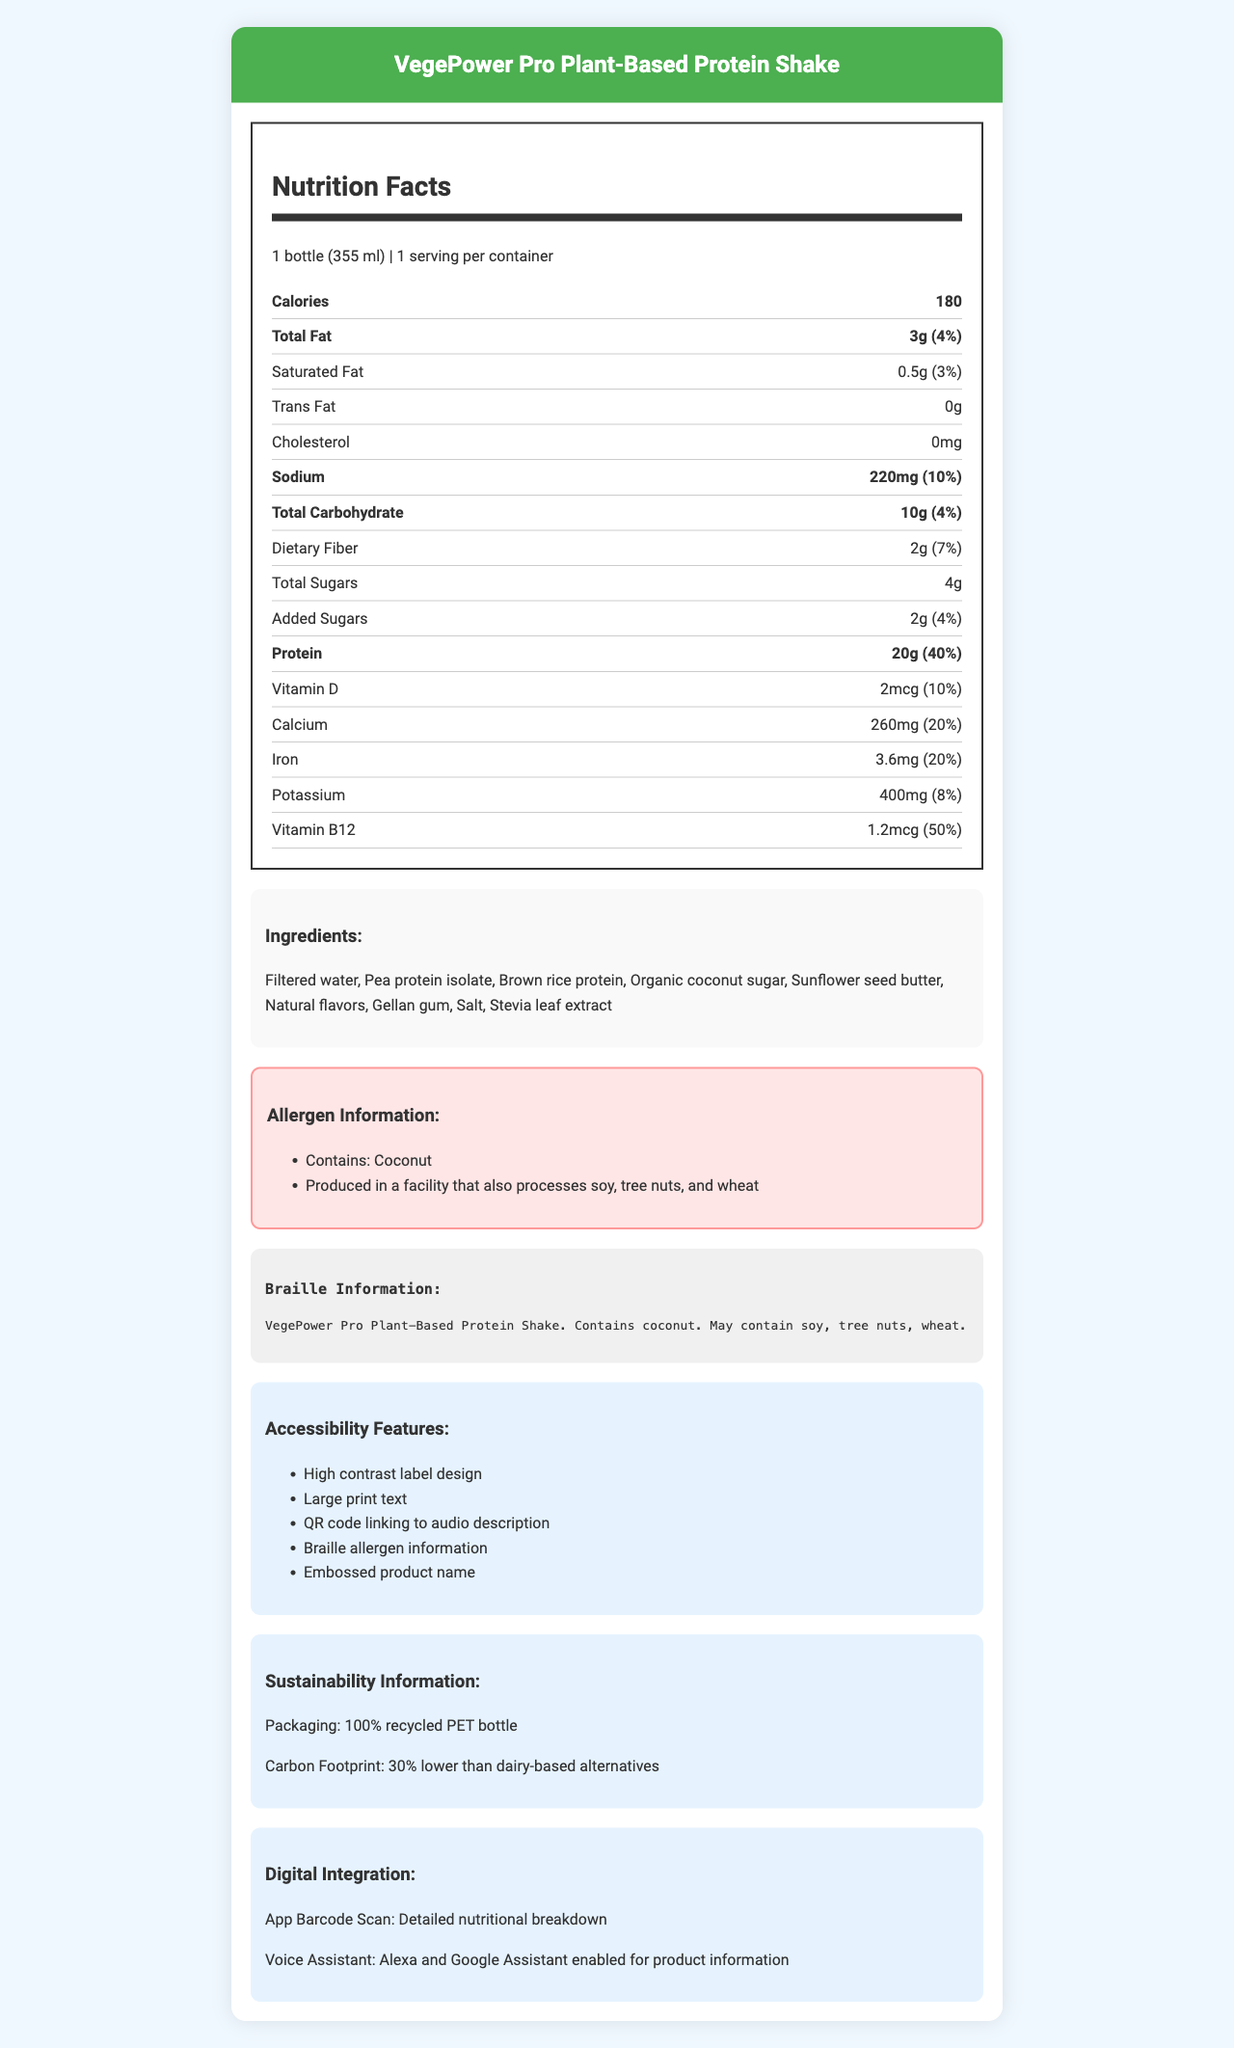what is the serving size for the VegePower Pro Plant-Based Protein Shake? The serving size is explicitly mentioned in the Nutrition Facts section of the document.
Answer: 1 bottle (355 ml) what is the total fat content in the protein shake? The total fat content and its percentage of the daily value are detailed in the Nutrition Facts section.
Answer: 3g (4% Daily Value) does the product contain any added sugars? If so, how much? The document lists "Added Sugars" as 2g, which is 4% of the daily value.
Answer: Yes, 2g (4% Daily Value) how much protein is in a single serving? The protein amount is outlined as 20g, which constitutes 40% of the daily value in the Nutrition Facts section.
Answer: 20g (40% Daily Value) what are the allergens listed for this product? The allergen information is provided in both the Allergy Information and Braille Information sections.
Answer: Coconut; may contain soy, tree nuts, wheat which vitamin contributes the most to the daily value per serving? A. Vitamin D B. Calcium C. Iron D. Vitamin B12 The product contains 1.2mcg of Vitamin B12, which is 50% of the daily value, making it the highest contributor in terms of percentage.
Answer: D. Vitamin B12 what is the primary protein source in the product? A. Whey protein B. Pea protein isolate C. Soy protein D. Hemp protein The ingredients list includes "Pea protein isolate" as the second ingredient, indicating it is a primary source of protein.
Answer: B. Pea protein isolate does the document provide information for visually impaired users? The document includes high contrast label design, large print text, a QR code linking to audio description, braille allergen information, and an embossed product name to aid visually impaired users.
Answer: Yes how does the carbon footprint of this product compare to dairy-based alternatives? The Sustainability Information section states that the carbon footprint is 30% lower compared to dairy-based alternatives.
Answer: 30% lower summarize the main features and information presented in the document This summary captures the main aspects covered in the document, encompassing nutrition details, accessibility, and sustainability.
Answer: The document provides comprehensive information about VegePower Pro Plant-Based Protein Shake, including detailed nutrition facts, ingredients, allergen information (in text and braille), accessibility features, sustainability data, and digital integration capabilities. The product aims to be inclusive and environmentally friendly, highlighting its lower carbon footprint and accessible design for visually impaired users. how is the product packaged? The Sustainability Information section specifies that the bottle is made from 100% recycled PET.
Answer: 100% recycled PET bottle does the label offer any digital interaction options? If so, what kind? The Digital Integration section lists these functionalities for enhanced user interaction with digital aids.
Answer: Yes, app barcode scan for detailed nutritional breakdown and voice assistant compatibility with Alexa and Google Assistant is the protein shake dairy-free? Although the product contains plant-based ingredients, the document does not explicitly state that the shake is dairy-free.
Answer: Cannot be determined what is the daily value percentage for calcium provided by one serving? The Nutrition Facts section mentions that one serving provides 260mg of calcium, which is 20% of the daily value.
Answer: 20% 